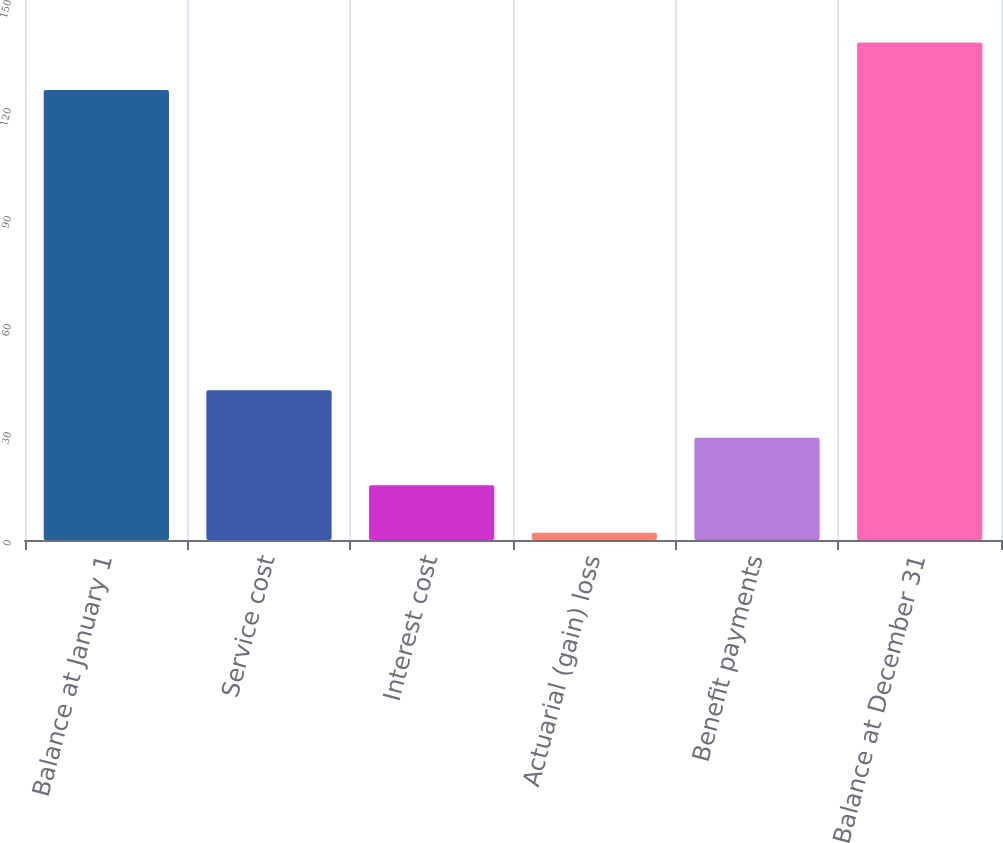Convert chart. <chart><loc_0><loc_0><loc_500><loc_500><bar_chart><fcel>Balance at January 1<fcel>Service cost<fcel>Interest cost<fcel>Actuarial (gain) loss<fcel>Benefit payments<fcel>Balance at December 31<nl><fcel>125<fcel>41.6<fcel>15.2<fcel>2<fcel>28.4<fcel>138.2<nl></chart> 